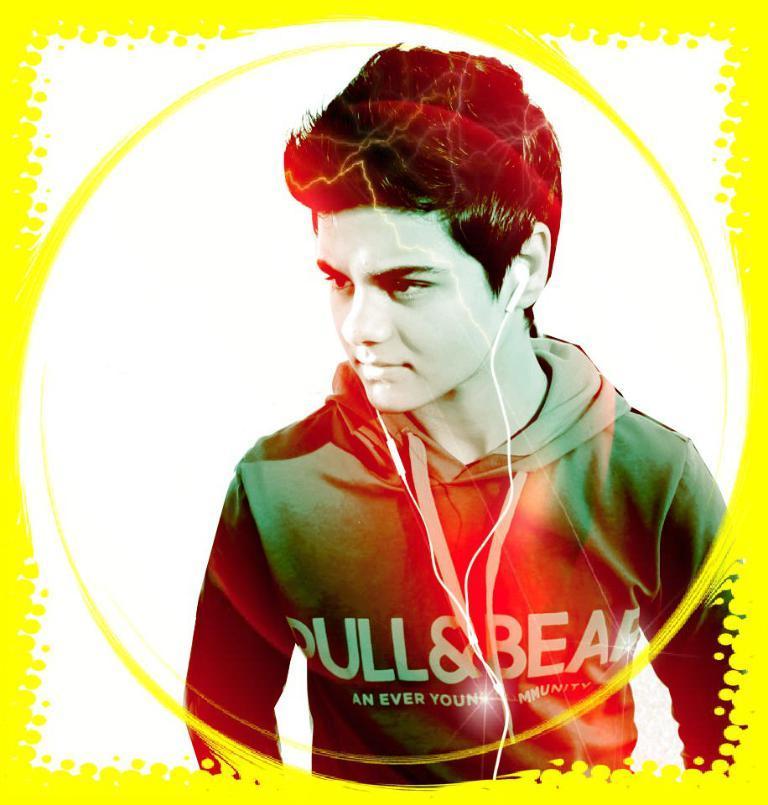Please provide a concise description of this image. This is an edited image. In this image we can see a man wearing headset. 